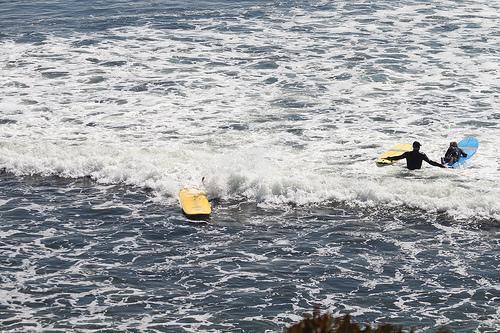How many people are surfing?
Give a very brief answer. 2. How many of the surfboards are yellow?
Give a very brief answer. 2. 